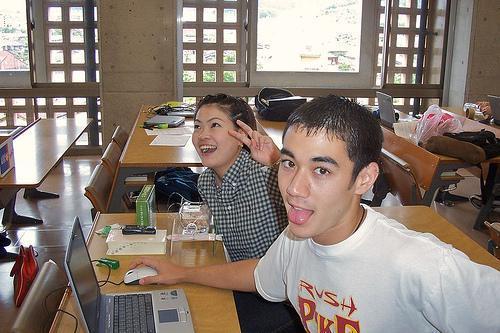How many fingers is the girl holding up?
Give a very brief answer. 2. How many people are at desk?
Give a very brief answer. 2. How many fingers does the woman have raised?
Give a very brief answer. 2. 